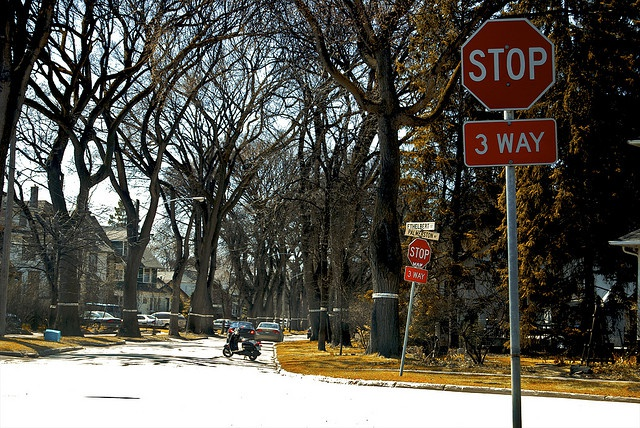Describe the objects in this image and their specific colors. I can see stop sign in black, maroon, and gray tones, motorcycle in black, gray, white, and darkgray tones, car in black, gray, white, and darkgray tones, stop sign in black, maroon, darkgray, and gray tones, and car in black, gray, darkgreen, and lightgray tones in this image. 